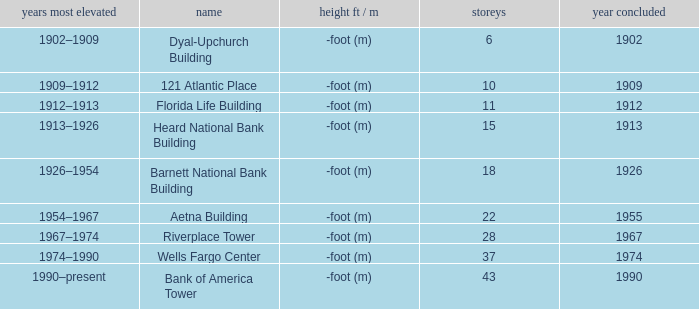What year was the building completed that has 10 floors? 1909.0. 